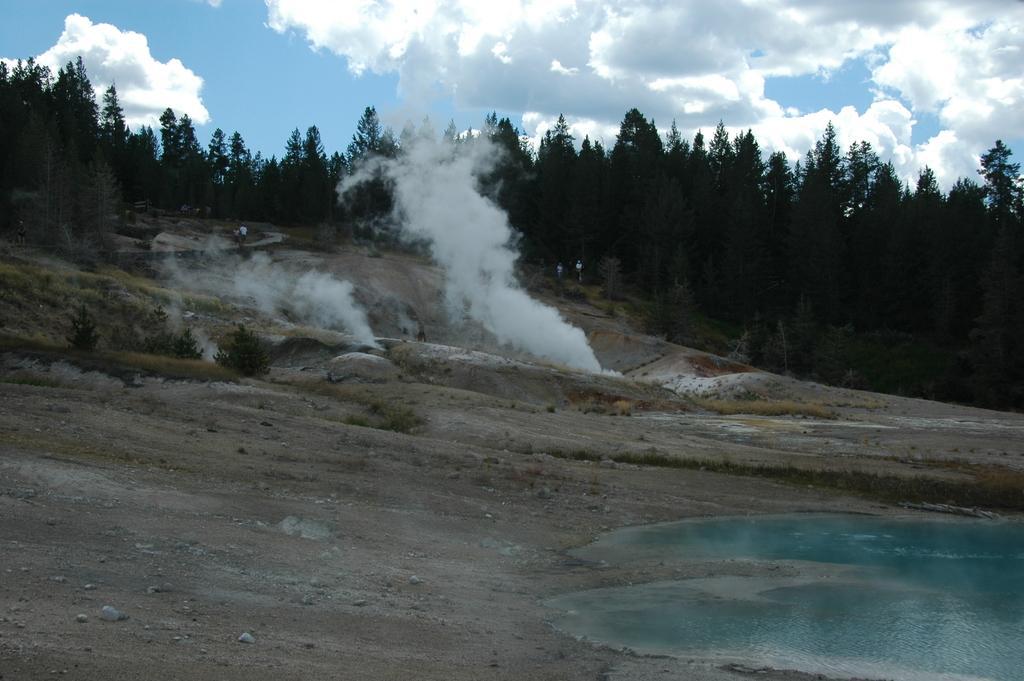How would you summarize this image in a sentence or two? In this image we can see water, smoke, grass, ground, trees, sky and clouds. 